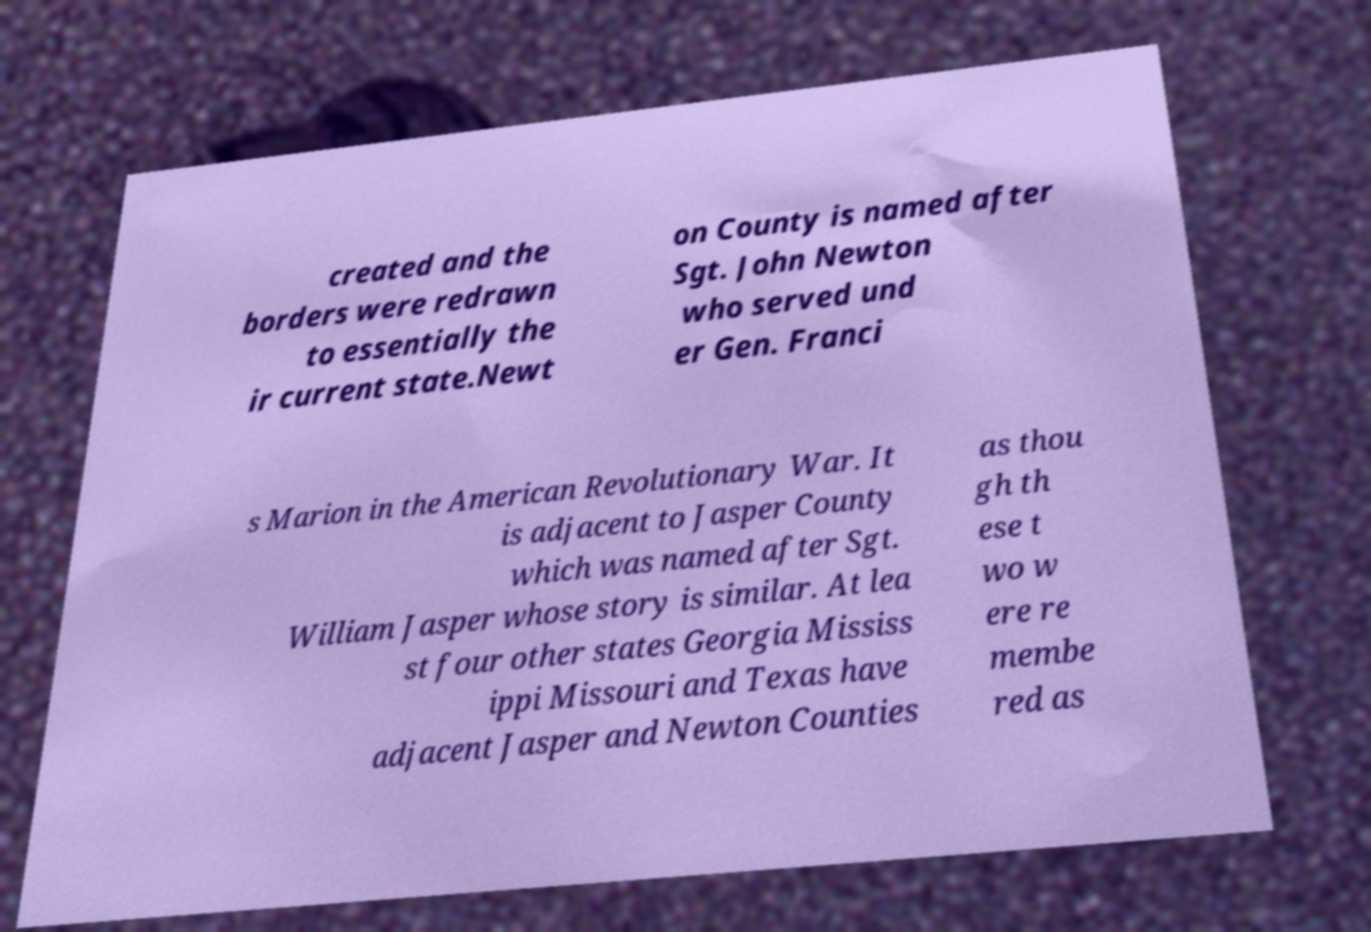For documentation purposes, I need the text within this image transcribed. Could you provide that? created and the borders were redrawn to essentially the ir current state.Newt on County is named after Sgt. John Newton who served und er Gen. Franci s Marion in the American Revolutionary War. It is adjacent to Jasper County which was named after Sgt. William Jasper whose story is similar. At lea st four other states Georgia Mississ ippi Missouri and Texas have adjacent Jasper and Newton Counties as thou gh th ese t wo w ere re membe red as 